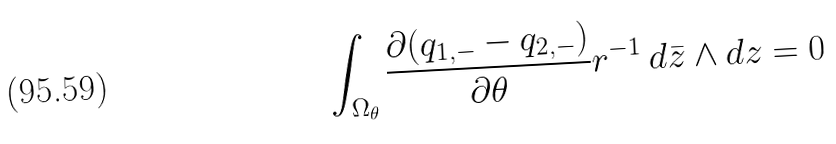<formula> <loc_0><loc_0><loc_500><loc_500>\int _ { \Omega _ { \theta } } \frac { \partial ( q _ { 1 , - } - q _ { 2 , - } ) } { \partial \theta } r ^ { - 1 } \, d \bar { z } \wedge d z = 0</formula> 